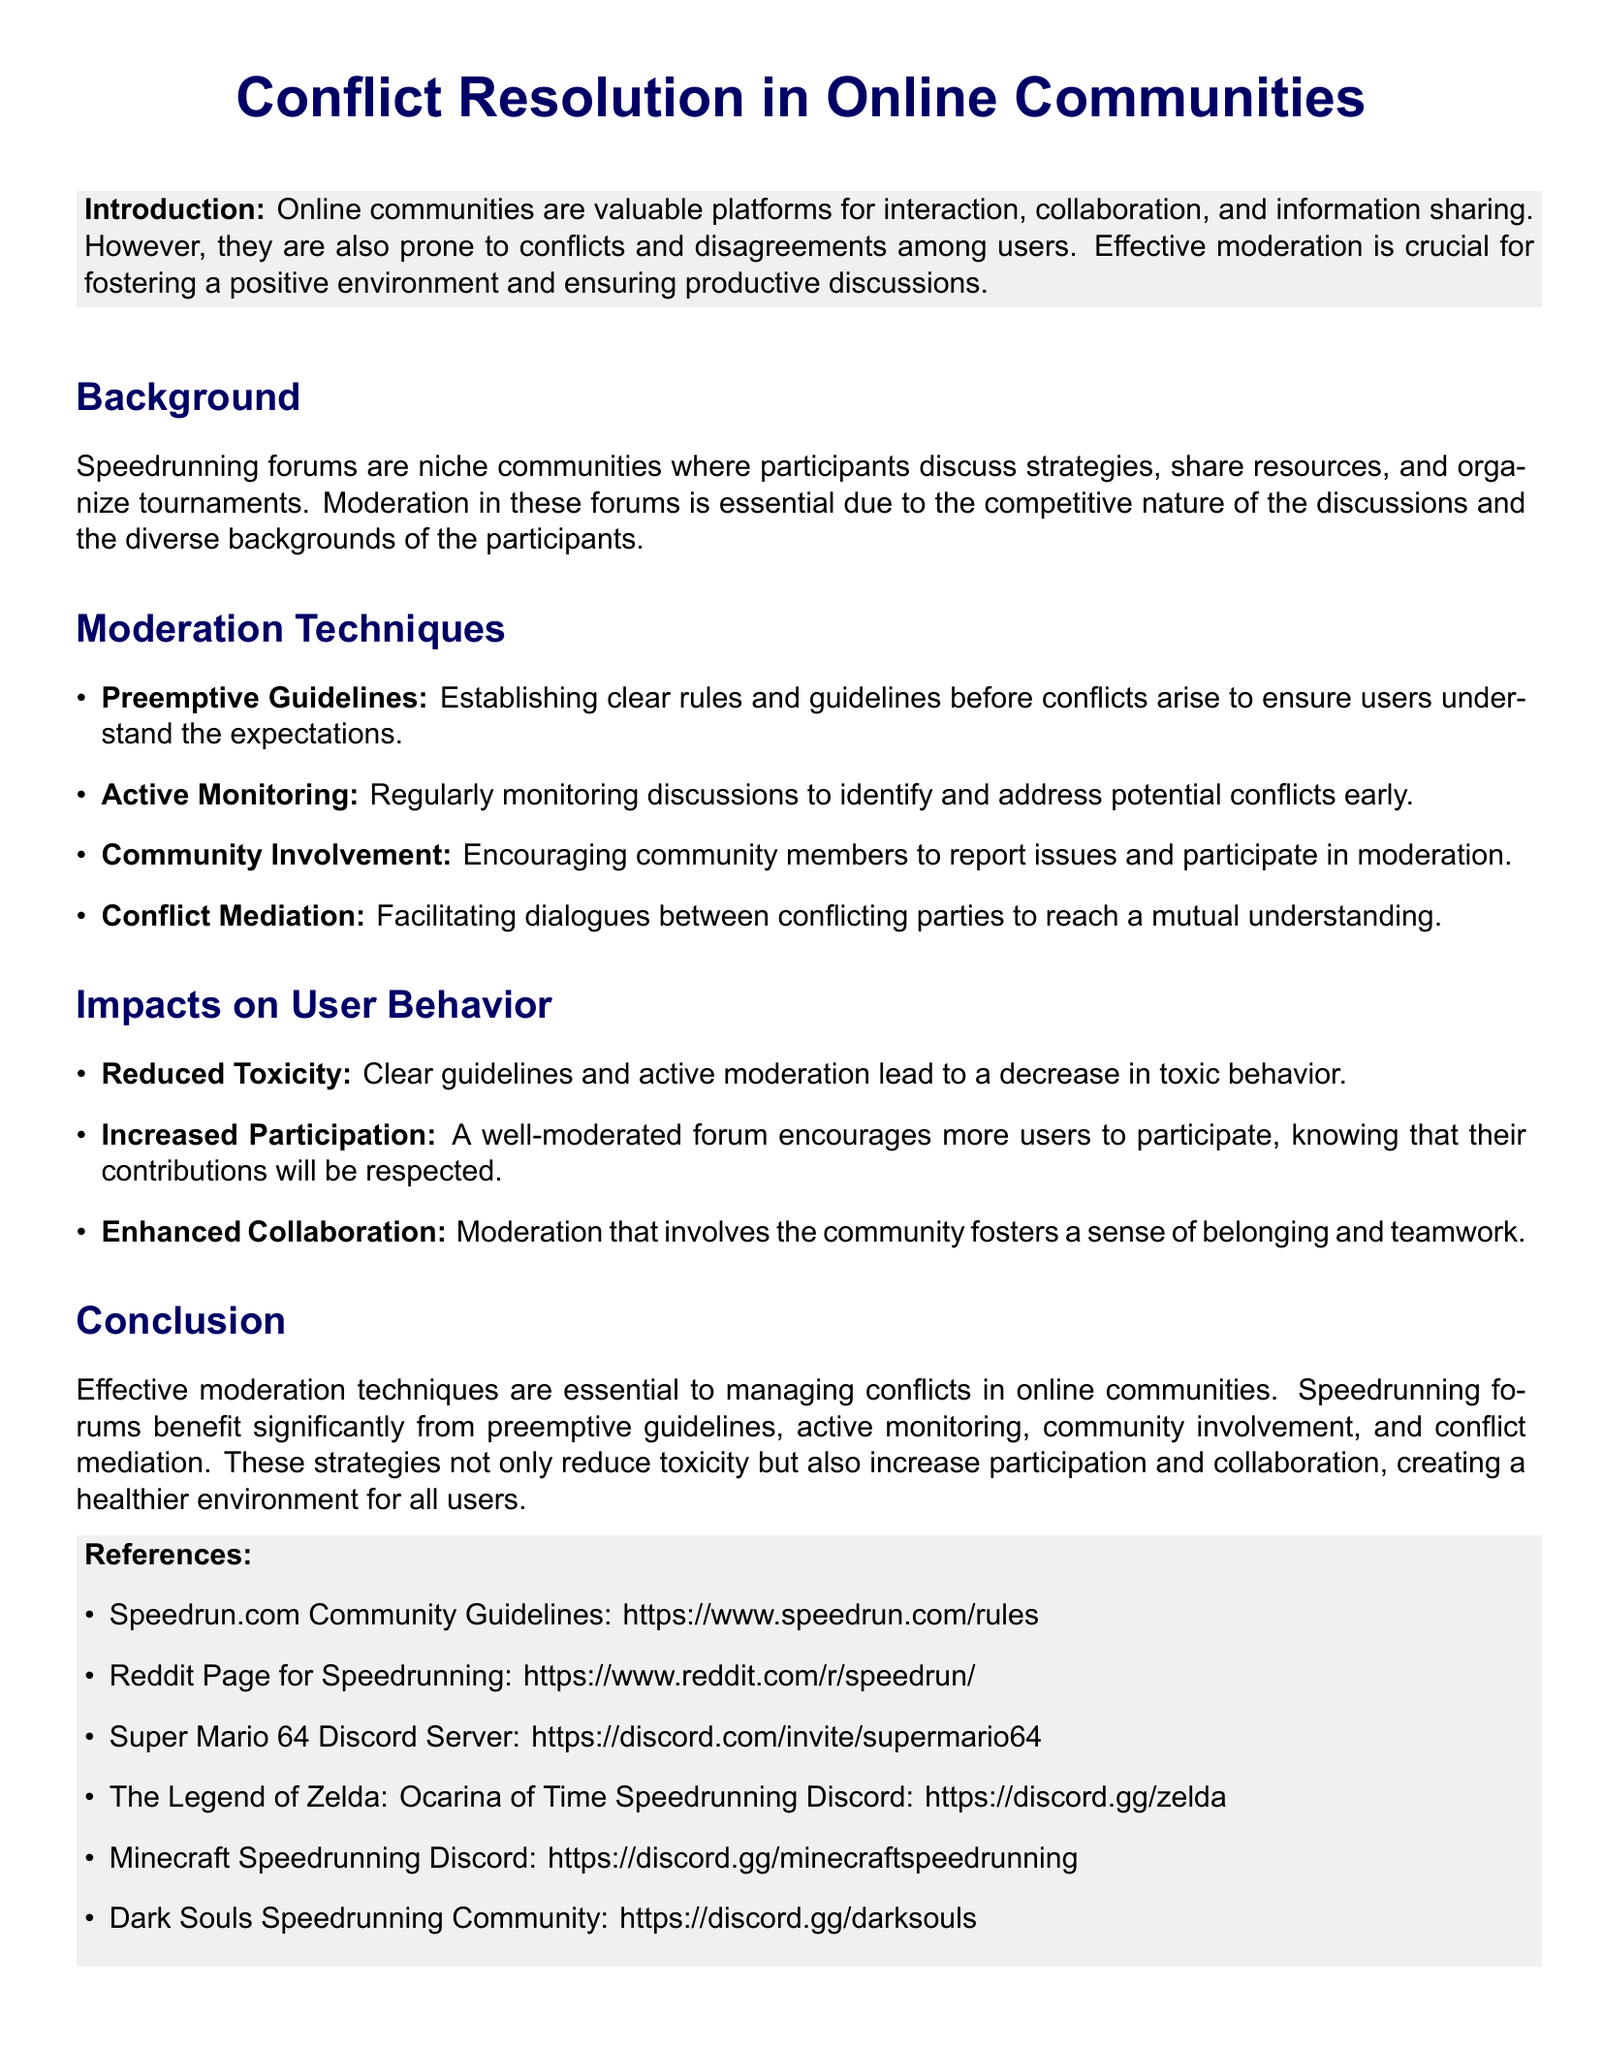What are the preemptive guidelines? Preemptive guidelines refer to the clear rules and guidelines established before conflicts arise to ensure users understand the expectations.
Answer: clear rules and guidelines What is the impact of conflict mediation? Conflict mediation is described as facilitating dialogues between conflicting parties to reach a mutual understanding.
Answer: mutual understanding What is one moderation technique listed in the document? The document lists several techniques, one of which is active monitoring, which involves regularly monitoring discussions to identify and address potential conflicts early.
Answer: active monitoring How has user behavior improved according to the impacts outlined? The document states that clear guidelines and active moderation lead to a decrease in toxic behavior.
Answer: Reduced Toxicity What is the primary focus of the case study? The primary focus of the case study is on conflict resolution in online communities, specifically examining moderation techniques and their impacts on user behavior.
Answer: conflict resolution in online communities How does effective moderation affect participation? The document notes that well-moderated forums encourage more users to participate, knowing that their contributions will be respected.
Answer: Increased Participation 